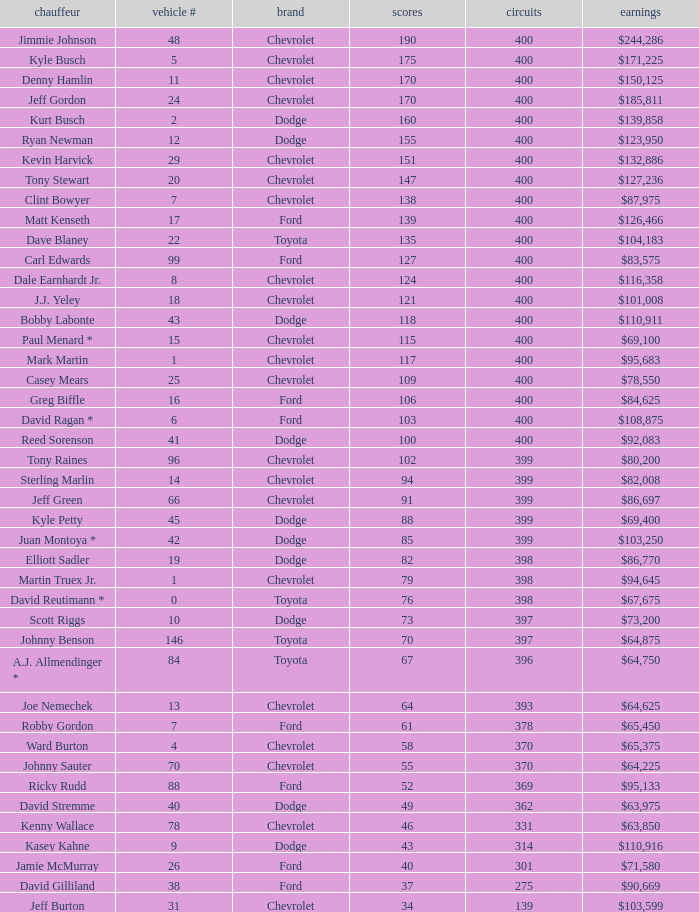What is the make of car 31? Chevrolet. 